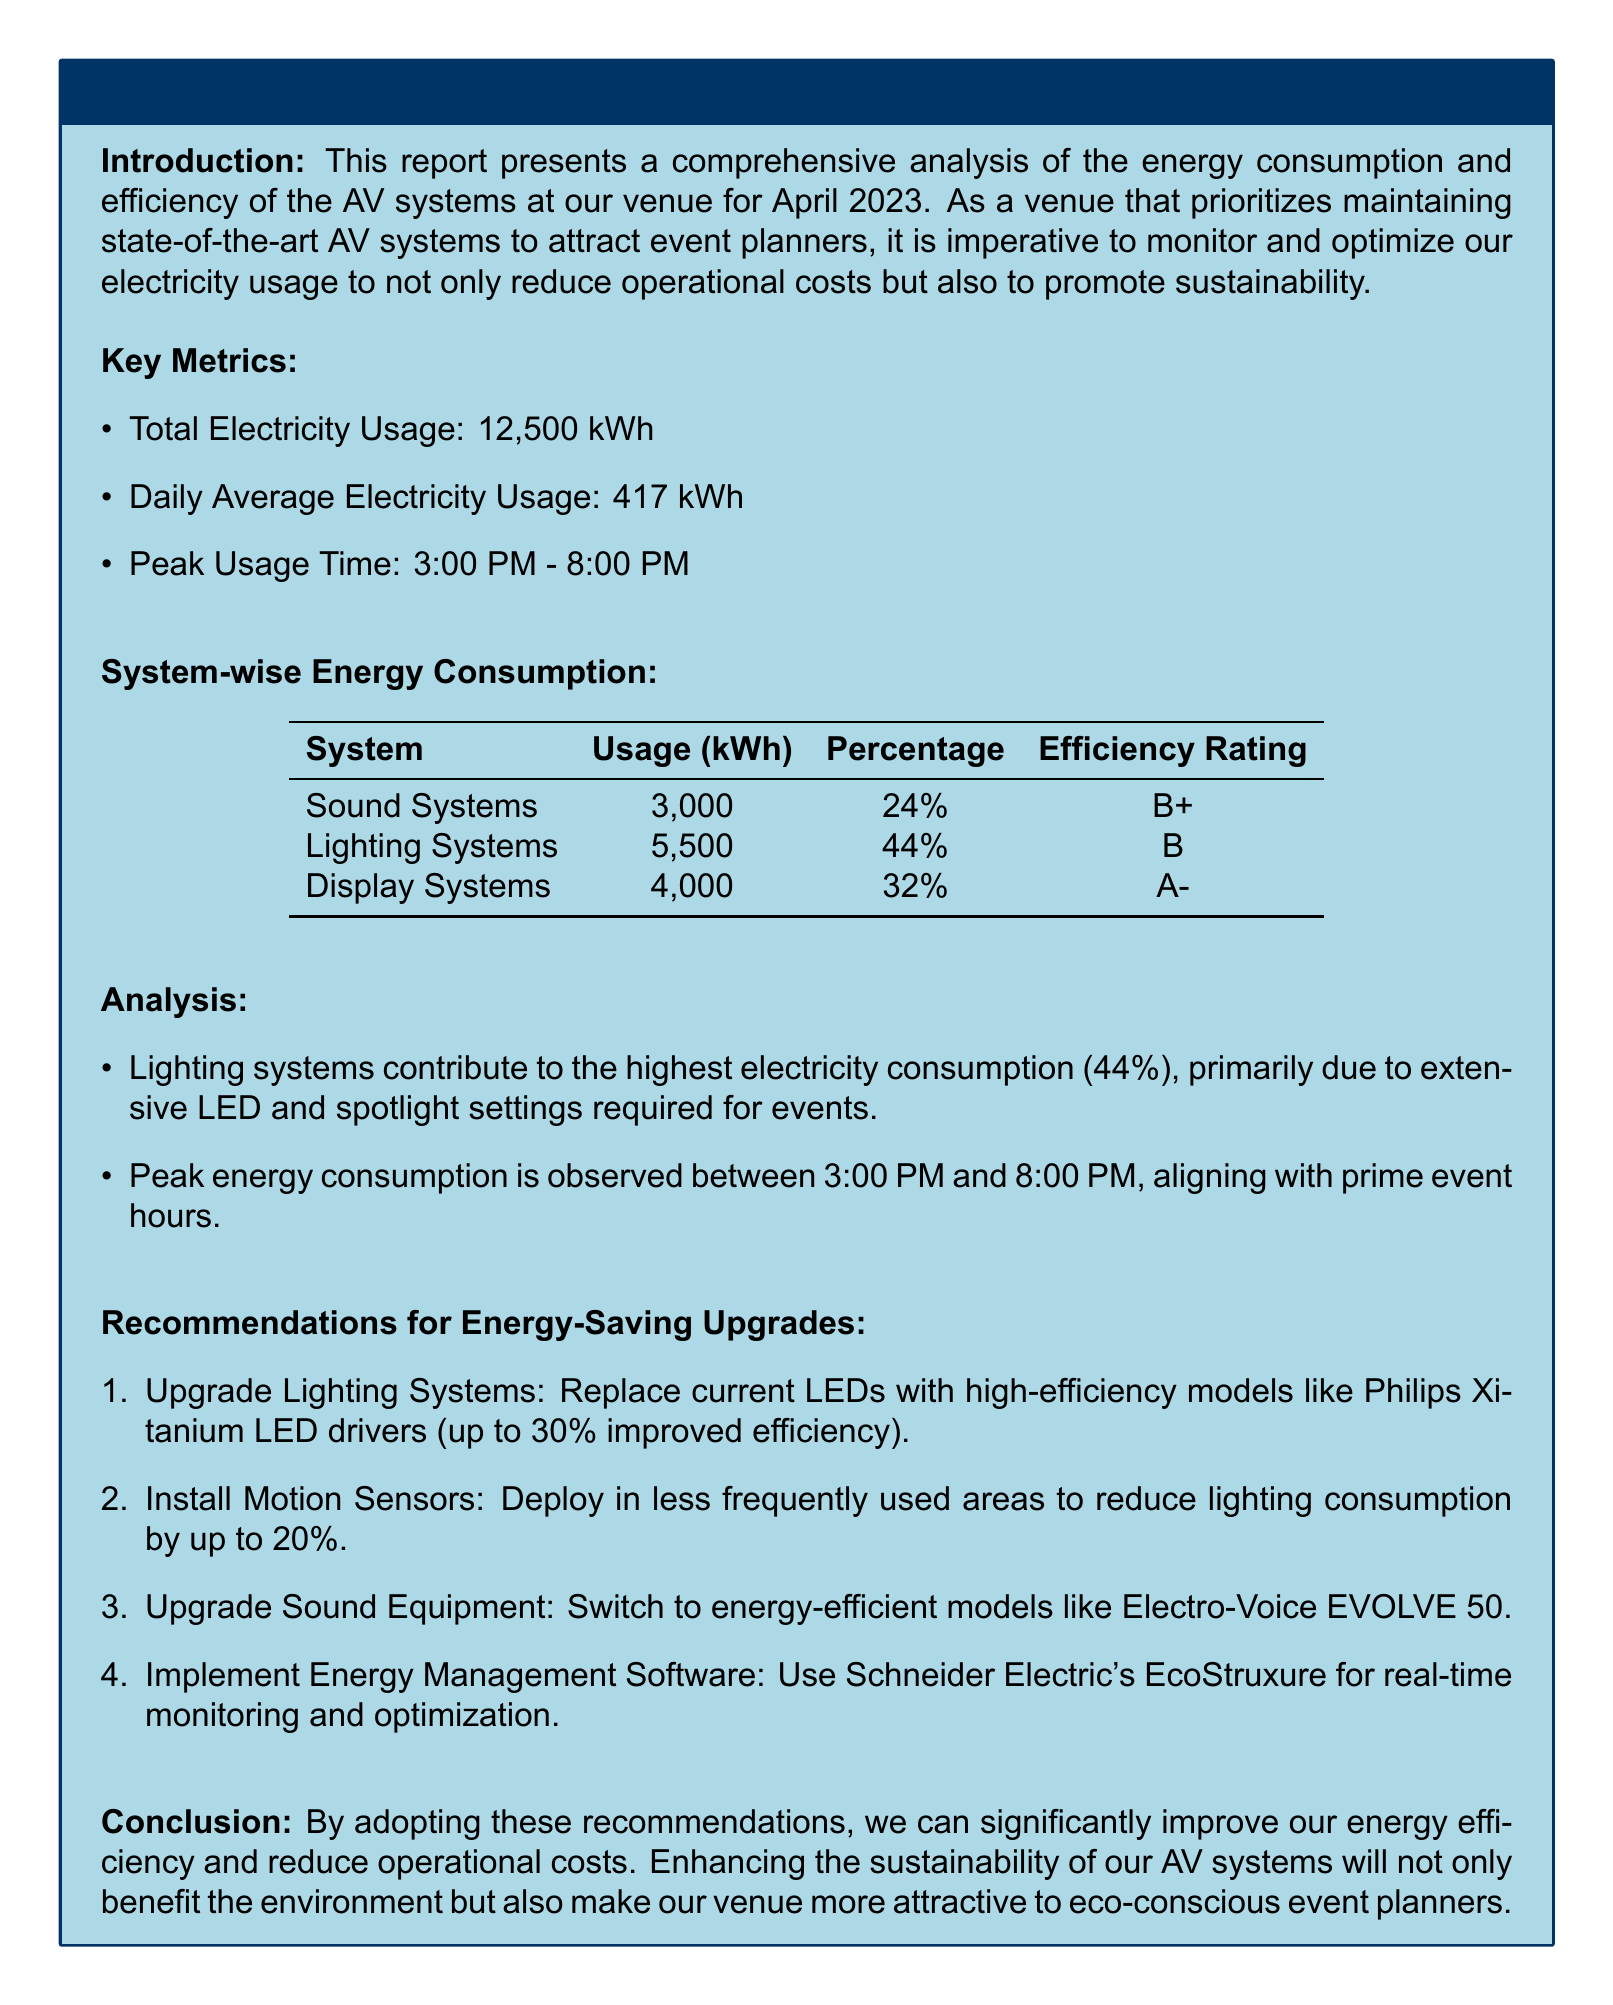What is the total electricity usage? The total electricity usage is listed under the Key Metrics section of the document, which states 12,500 kWh.
Answer: 12,500 kWh What percentage of total consumption do display systems represent? The percentage of total consumption for display systems is provided in the System-wise Energy Consumption table, which lists it as 32%.
Answer: 32% What is the efficiency rating of the lighting systems? The efficiency rating for the lighting systems can be found in the System-wise Energy Consumption table, where it is rated as B.
Answer: B What time frame represents peak usage? The peak usage time is mentioned in the Key Metrics section of the report, indicating the specific time frame.
Answer: 3:00 PM - 8:00 PM Which AV system has the highest electricity consumption? The document specifies the highest consumption in the System-wise Energy Consumption table, identifying lighting systems as the leading consumer.
Answer: Lighting Systems How much can motion sensors reduce lighting consumption? The document states that motion sensors can reduce lighting consumption by up to a certain percentage, which is provided in the Recommendations section.
Answer: 20% What is one of the suggested upgrades for the lighting systems? The recommendations for upgrades include replacing current LEDs with high-efficiency models, specified in the Recommendations section.
Answer: Philips Xitanium LED drivers What software is recommended for monitoring energy usage? The document suggests specific energy management software in the Recommendations section, offering a name for it.
Answer: Schneider Electric's EcoStruxure How can upgrading sound equipment affect energy consumption? The recommendations mention a specific energy-efficient model that can help reduce energy consumption in sound equipment.
Answer: Electro-Voice EVOLVE 50 